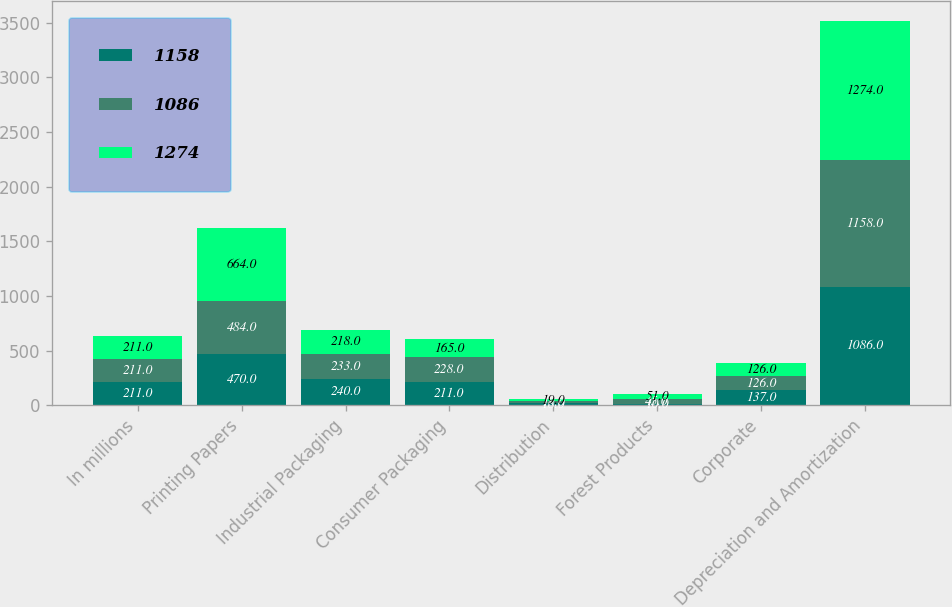Convert chart to OTSL. <chart><loc_0><loc_0><loc_500><loc_500><stacked_bar_chart><ecel><fcel>In millions<fcel>Printing Papers<fcel>Industrial Packaging<fcel>Consumer Packaging<fcel>Distribution<fcel>Forest Products<fcel>Corporate<fcel>Depreciation and Amortization<nl><fcel>1158<fcel>211<fcel>470<fcel>240<fcel>211<fcel>18<fcel>10<fcel>137<fcel>1086<nl><fcel>1086<fcel>211<fcel>484<fcel>233<fcel>228<fcel>18<fcel>45<fcel>126<fcel>1158<nl><fcel>1274<fcel>211<fcel>664<fcel>218<fcel>165<fcel>19<fcel>51<fcel>126<fcel>1274<nl></chart> 